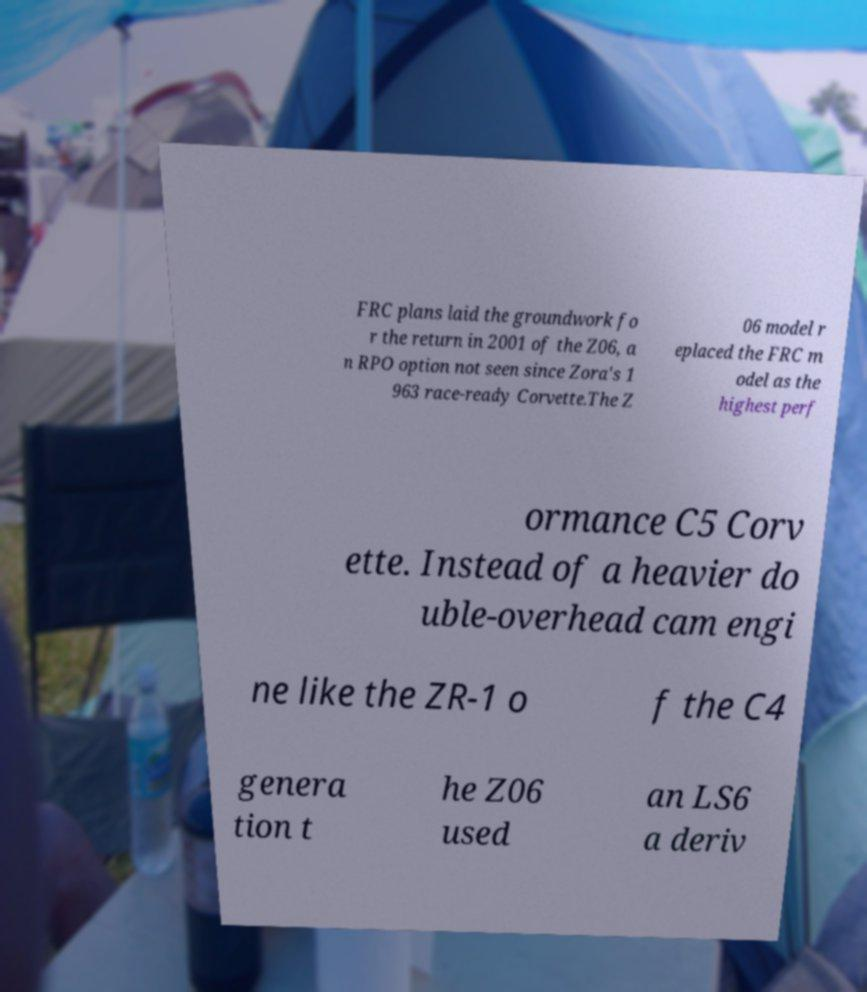Could you extract and type out the text from this image? FRC plans laid the groundwork fo r the return in 2001 of the Z06, a n RPO option not seen since Zora's 1 963 race-ready Corvette.The Z 06 model r eplaced the FRC m odel as the highest perf ormance C5 Corv ette. Instead of a heavier do uble-overhead cam engi ne like the ZR-1 o f the C4 genera tion t he Z06 used an LS6 a deriv 